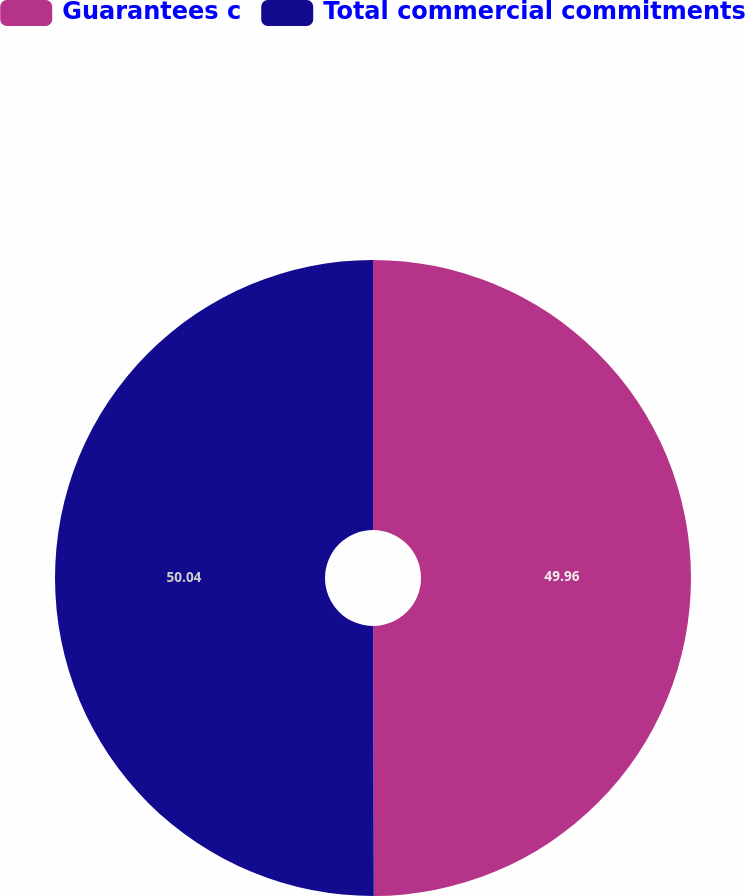<chart> <loc_0><loc_0><loc_500><loc_500><pie_chart><fcel>Guarantees c<fcel>Total commercial commitments<nl><fcel>49.96%<fcel>50.04%<nl></chart> 